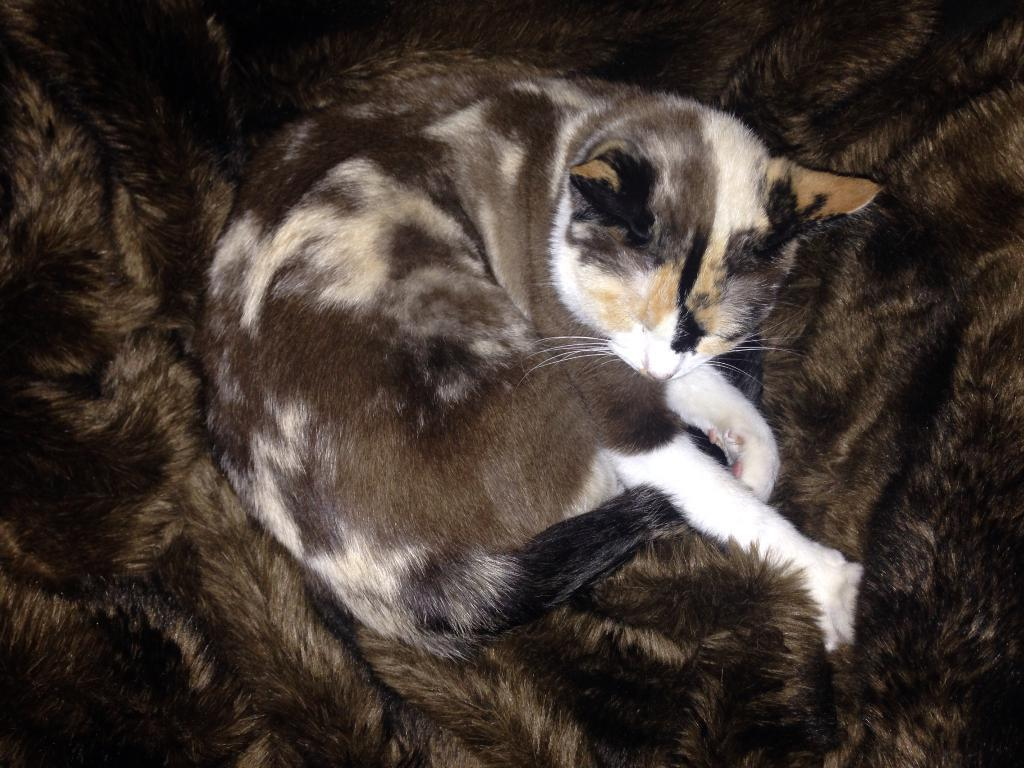What animal is present in the image? There is a cat in the image. What is the cat doing in the image? The cat is sleeping. What color scheme is used for the cat in the image? The cat is in black and white color. What is the price of the crayon in the image? There is no crayon present in the image, so it is not possible to determine its price. 